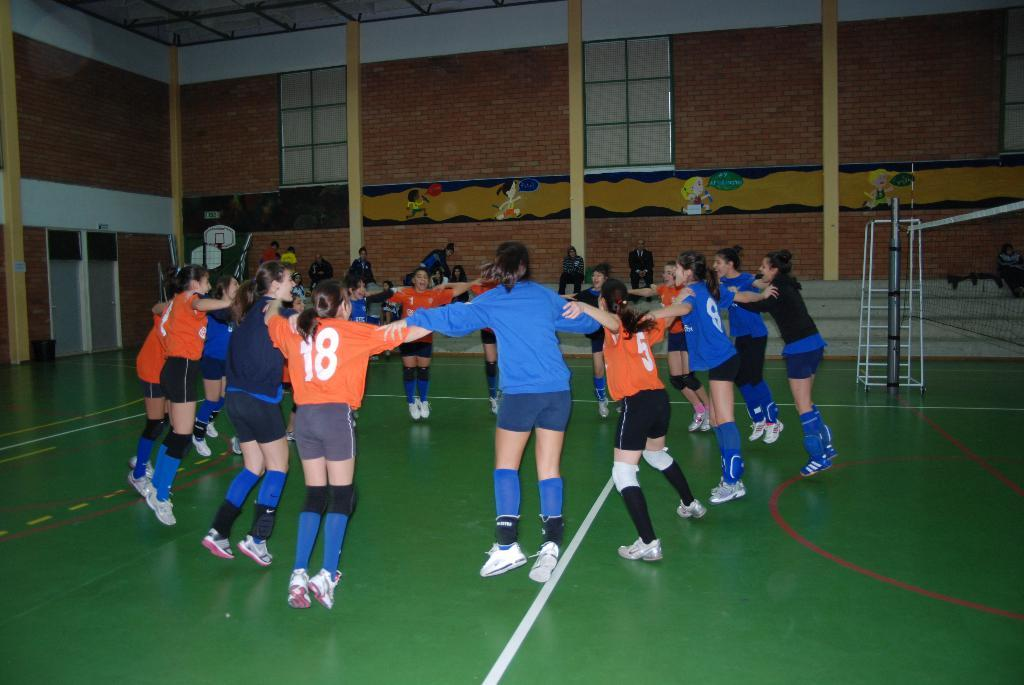<image>
Write a terse but informative summary of the picture. An athlete with the number 18 on her shirt. 